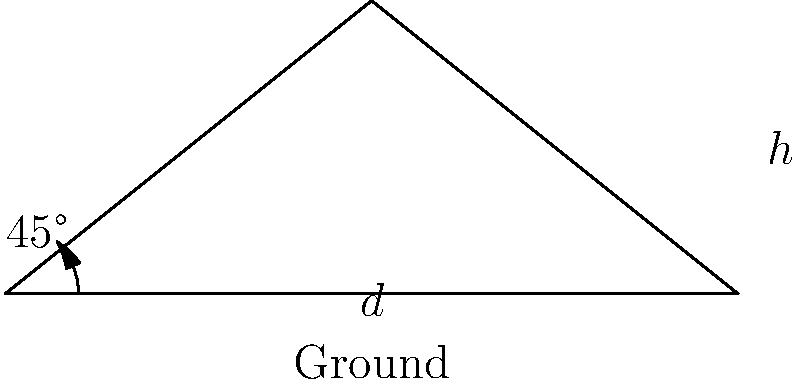During a long pass in the 1952 season, you observed the football's trajectory forming a 45-degree angle with the ground at the point of release. If the pass traveled a horizontal distance of 40 yards before being caught, what was the maximum height reached by the football? (Assume the path of the football forms a parabola and ignore air resistance.) Let's approach this step-by-step:

1) In a projectile motion where the launch angle is 45°, the trajectory forms a symmetrical parabola. This means that the maximum height (h) is reached at half the horizontal distance (d/2).

2) In a 45-45-90 triangle, the ratio of the side lengths is 1 : 1 : $\sqrt{2}$. This means that at the apex of the trajectory, the height and half the horizontal distance are equal.

3) Given:
   - Horizontal distance (d) = 40 yards
   - Launch angle = 45°

4) The maximum height occurs at half the horizontal distance:
   $\frac{d}{2} = \frac{40}{2} = 20$ yards

5) Due to the properties of the 45-45-90 triangle, the maximum height (h) is equal to half the horizontal distance:

   $h = 20$ yards

Therefore, the maximum height reached by the football is 20 yards.
Answer: 20 yards 